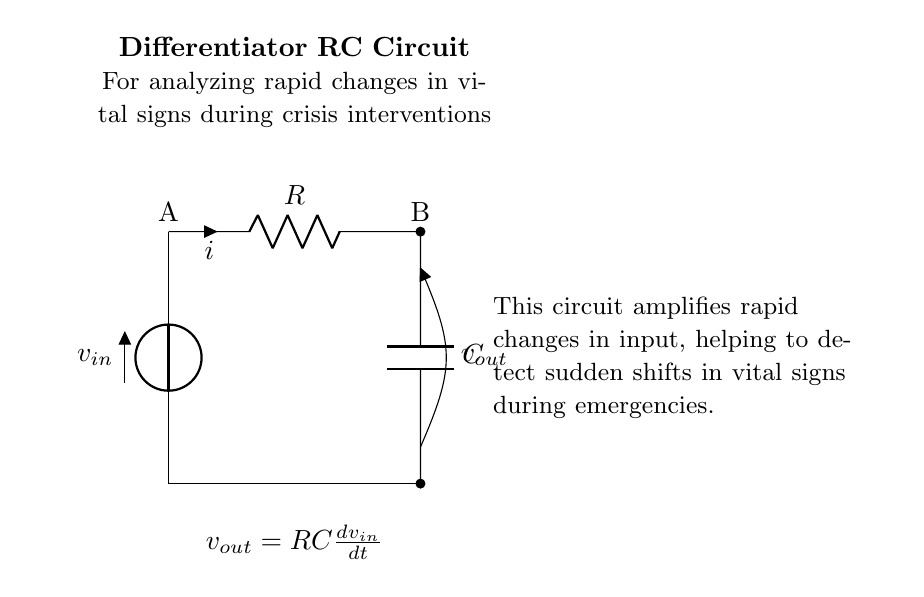What is the type of circuit shown? The circuit is a differentiator RC circuit, indicated by the configuration of the resistor and capacitor aimed at amplifying rapid changes in voltage.
Answer: Differentiator RC circuit What does the output voltage represent? The output voltage, noted as v_out, is derived from the input voltage's rate of change, according to the equation shown in the diagram, demonstrating how quickly the input voltage is changing over time.
Answer: Rate of change of input voltage What are the two components in the circuit? The circuit contains a resistor and a capacitor, which are essential for creating the differentiation effect needed for analyzing rapid changes in voltage.
Answer: Resistor and capacitor What is the relationship expressed in the equation? The equation v_out = RC(dv_in/dt) shows that the output voltage is proportional to both the resistance, capacitance, and the time derivative of the input voltage, indicating how quickly the input is changing.
Answer: Output voltage is proportional to derivative of input voltage What is the role of the capacitor in this circuit? The capacitor acts to store and release charge, which in conjunction with the resistor allows the circuit to respond to rapid changes in the input voltage, effectively differentiating it over time.
Answer: To store and release charge How does the resistor affect the circuit's behavior? The resistor determines the time constant of the circuit in conjunction with the capacitor, affecting how quickly the circuit reacts to changes in input voltage and thereby influencing the output signal.
Answer: Determines time constant 